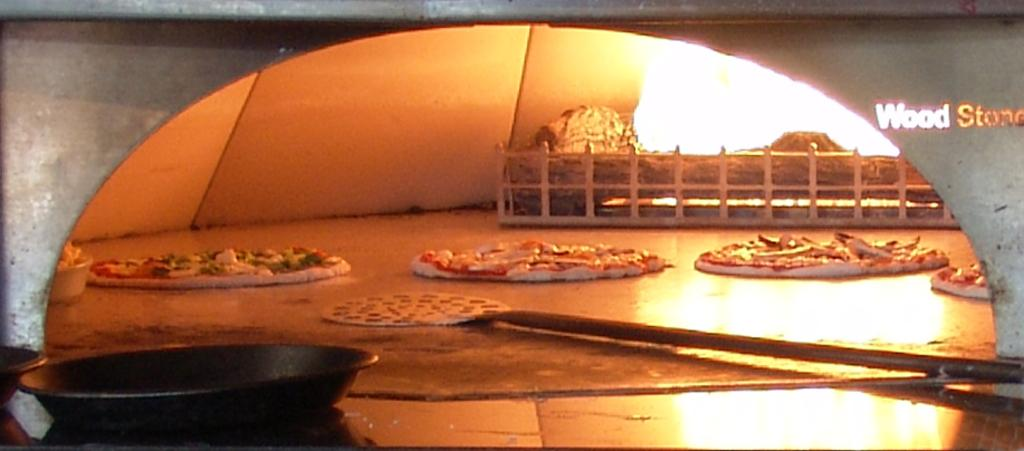<image>
Give a short and clear explanation of the subsequent image. Pizzd is baking in an oven with has "Wood Stone" in gold letters to one side. 